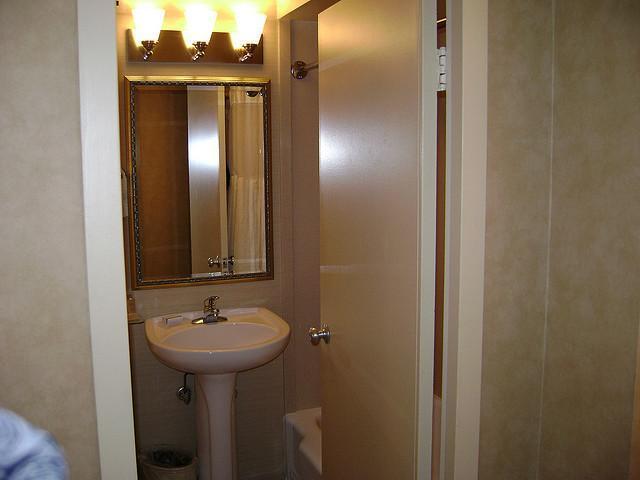How many light in the shot?
Give a very brief answer. 3. How many trains are pulling into the station?
Give a very brief answer. 0. 